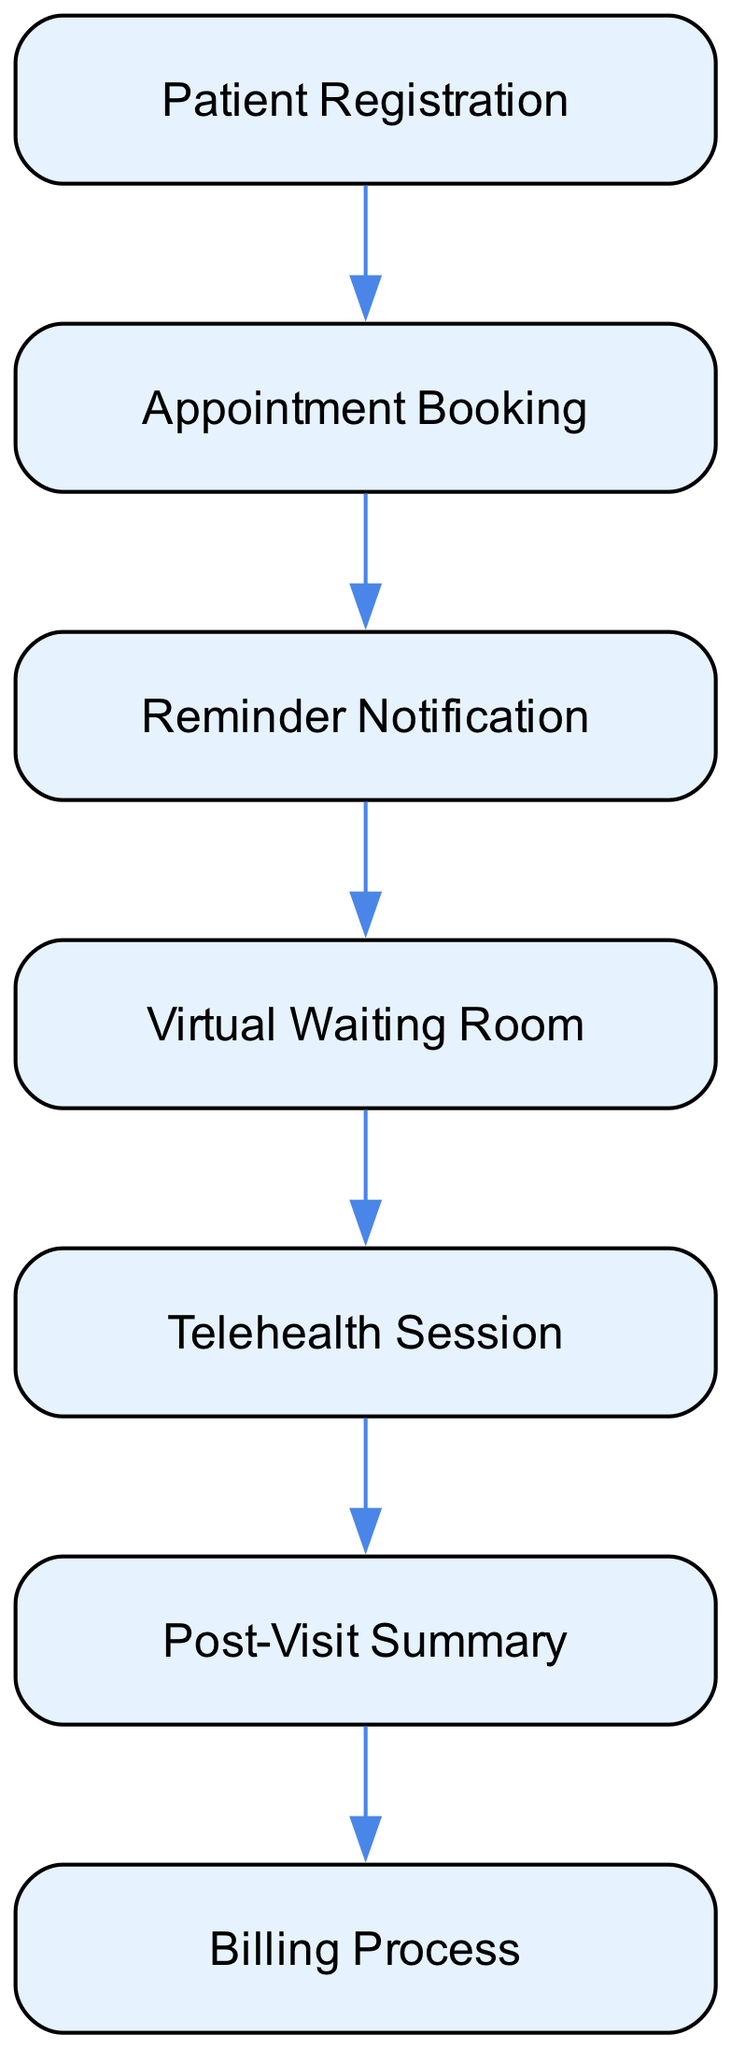What is the first step in the telehealth consultation workflow? The first step in the workflow is the "Patient Registration." This is identified as the starting point of the flowchart, and it includes the patient's action of filling out the registration form.
Answer: Patient Registration How many nodes are there in the diagram? The diagram contains seven nodes representing various steps in the telehealth consultation workflow. Each distinct process from registration to billing is counted as a node.
Answer: Seven What occurs after "Appointment Booking"? After "Appointment Booking," the next step is "Reminder Notification." This follows the appointment scheduling process and serves as a prompt to remind the patient of their scheduled consultation.
Answer: Reminder Notification Which step directly precedes the "Telehealth Session"? The step that directly precedes the "Telehealth Session" is the "Virtual Waiting Room." Patients have to enter the waiting room before they can consult with the healthcare provider.
Answer: Virtual Waiting Room What is the last step in the workflow? The last step in the workflow is the "Billing Process." This concludes the telehealth consultation and involves the handling of insurance processing and patient payments.
Answer: Billing Process How many edges are present in the diagram? The diagram has six edges, as each edge indicates the flow from one step to the next, starting from Patient Registration to Billing Process. Total edges are counted between each sequential node.
Answer: Six Which two steps are connected directly by an edge? The "Appointment Booking" and "Reminder Notification" are connected directly by an edge. This indicates a direct sequence in the telehealth consultation workflow.
Answer: Appointment Booking, Reminder Notification What is sent to the patient after the "Telehealth Session"? After the "Telehealth Session," the provider sends a "Post-Visit Summary" to the patient. This communication typically includes details such as a visit summary and treatment plan.
Answer: Post-Visit Summary What type of notifications does a patient receive before their appointment? A patient receives "Reminder Notification" which can be sent via email or SMS. This step is crucial to ensure the patient is aware of their upcoming appointment.
Answer: Reminder Notification 